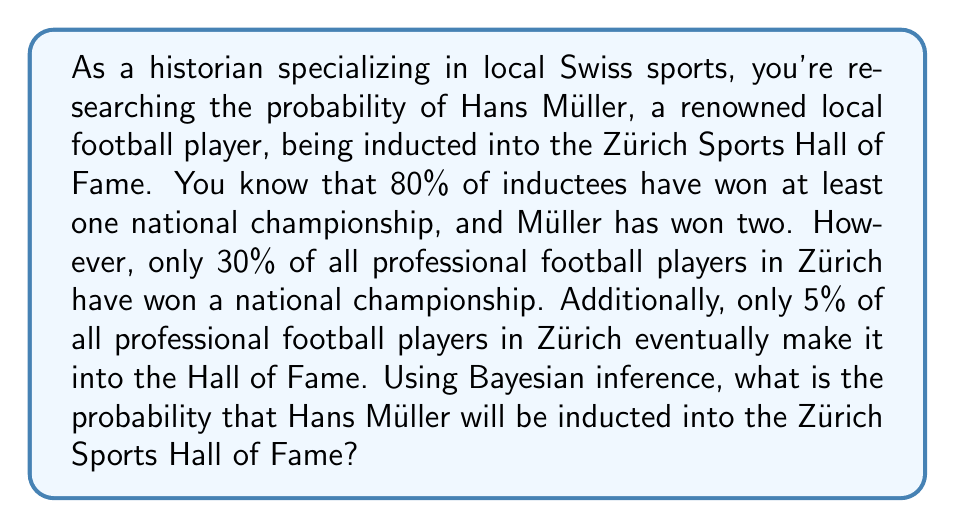Provide a solution to this math problem. To solve this problem using Bayesian inference, we'll follow these steps:

1. Define our events:
   A: Being inducted into the Hall of Fame
   B: Winning at least one national championship

2. Given information:
   P(B|A) = 0.80 (probability of winning a championship given induction)
   P(B) = 0.30 (probability of winning a championship)
   P(A) = 0.05 (probability of being inducted)

3. We want to find P(A|B), the probability of being inducted given that Müller has won championships.

4. We'll use Bayes' theorem:

   $$P(A|B) = \frac{P(B|A) \cdot P(A)}{P(B)}$$

5. Substituting the values:

   $$P(A|B) = \frac{0.80 \cdot 0.05}{0.30}$$

6. Calculating:

   $$P(A|B) = \frac{0.04}{0.30} = \frac{2}{15} \approx 0.1333$$

7. Convert to a percentage:

   0.1333 * 100 ≈ 13.33%

Therefore, based on Bayesian inference, the probability that Hans Müller will be inducted into the Zürich Sports Hall of Fame, given that he has won national championships, is approximately 13.33%.
Answer: The probability that Hans Müller will be inducted into the Zürich Sports Hall of Fame is approximately 13.33%. 